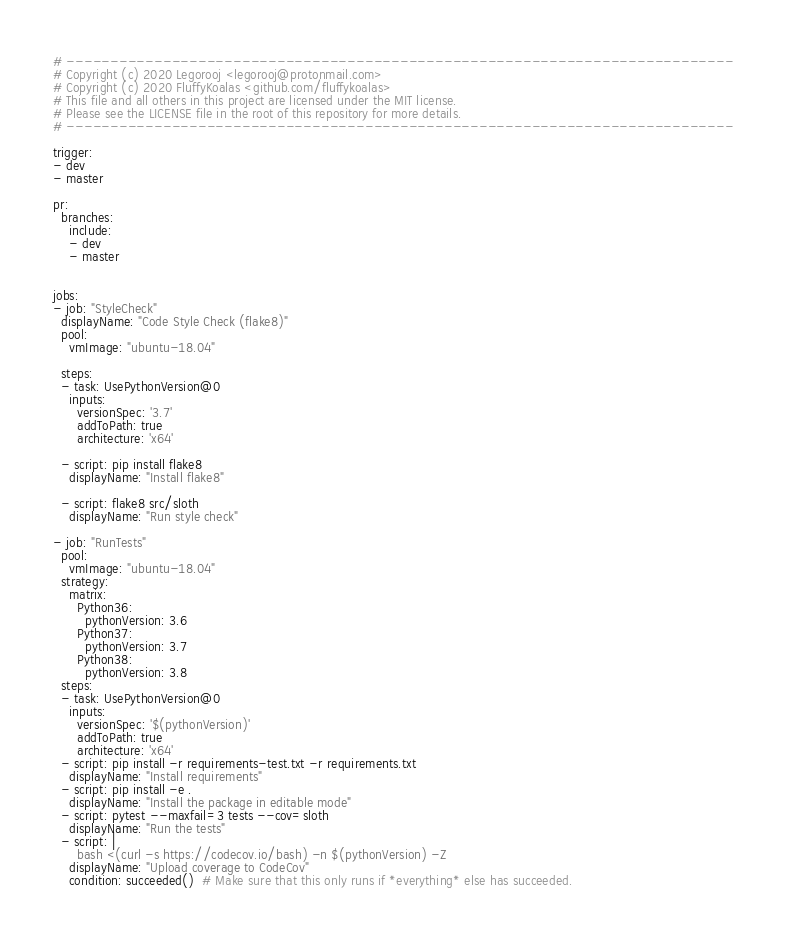<code> <loc_0><loc_0><loc_500><loc_500><_YAML_># ----------------------------------------------------------------------------
# Copyright (c) 2020 Legorooj <legorooj@protonmail.com>
# Copyright (c) 2020 FluffyKoalas <github.com/fluffykoalas>
# This file and all others in this project are licensed under the MIT license.
# Please see the LICENSE file in the root of this repository for more details.
# ----------------------------------------------------------------------------

trigger:
- dev
- master

pr:
  branches:
    include:
    - dev
    - master


jobs: 
- job: "StyleCheck"
  displayName: "Code Style Check (flake8)"
  pool:
    vmImage: "ubuntu-18.04"

  steps:  
  - task: UsePythonVersion@0
    inputs:
      versionSpec: '3.7'
      addToPath: true
      architecture: 'x64'

  - script: pip install flake8
    displayName: "Install flake8"

  - script: flake8 src/sloth
    displayName: "Run style check"

- job: "RunTests"
  pool:
    vmImage: "ubuntu-18.04"
  strategy:
    matrix:
      Python36:
        pythonVersion: 3.6
      Python37:
        pythonVersion: 3.7
      Python38:
        pythonVersion: 3.8
  steps:
  - task: UsePythonVersion@0
    inputs:
      versionSpec: '$(pythonVersion)'
      addToPath: true
      architecture: 'x64'
  - script: pip install -r requirements-test.txt -r requirements.txt
    displayName: "Install requirements"
  - script: pip install -e .
    displayName: "Install the package in editable mode"
  - script: pytest --maxfail=3 tests --cov=sloth
    displayName: "Run the tests"
  - script: |
      bash <(curl -s https://codecov.io/bash) -n $(pythonVersion) -Z
    displayName: "Upload coverage to CodeCov"
    condition: succeeded()  # Make sure that this only runs if *everything* else has succeeded.
</code> 